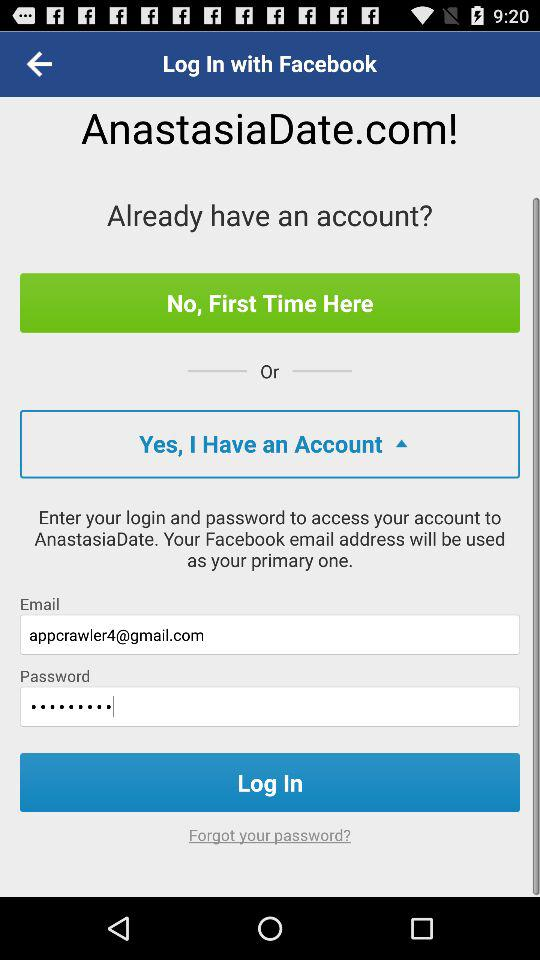Which website or page is this? The website is anastasiadate.com. 